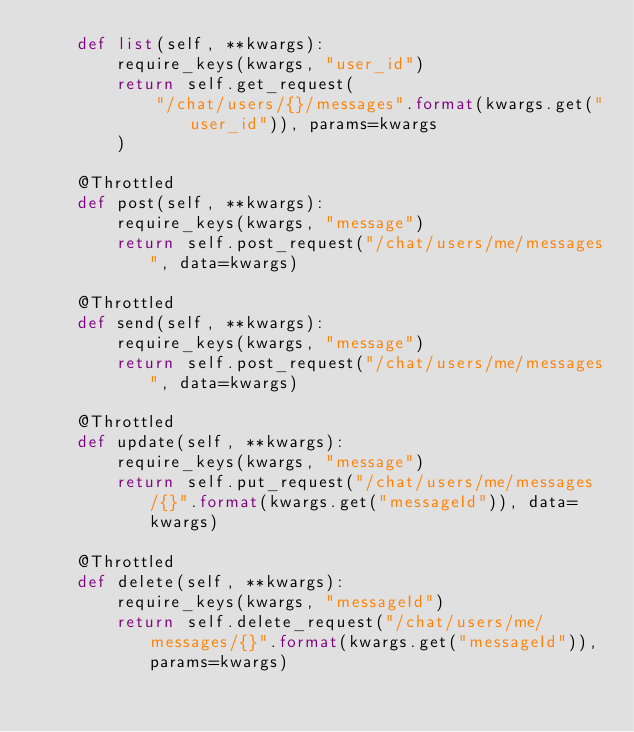Convert code to text. <code><loc_0><loc_0><loc_500><loc_500><_Python_>    def list(self, **kwargs):
        require_keys(kwargs, "user_id")
        return self.get_request(
            "/chat/users/{}/messages".format(kwargs.get("user_id")), params=kwargs
        )

    @Throttled
    def post(self, **kwargs):
        require_keys(kwargs, "message")
        return self.post_request("/chat/users/me/messages", data=kwargs)

    @Throttled
    def send(self, **kwargs):
        require_keys(kwargs, "message")
        return self.post_request("/chat/users/me/messages", data=kwargs)

    @Throttled
    def update(self, **kwargs):
        require_keys(kwargs, "message")
        return self.put_request("/chat/users/me/messages/{}".format(kwargs.get("messageId")), data=kwargs)

    @Throttled
    def delete(self, **kwargs):
        require_keys(kwargs, "messageId")
        return self.delete_request("/chat/users/me/messages/{}".format(kwargs.get("messageId")), params=kwargs)
</code> 